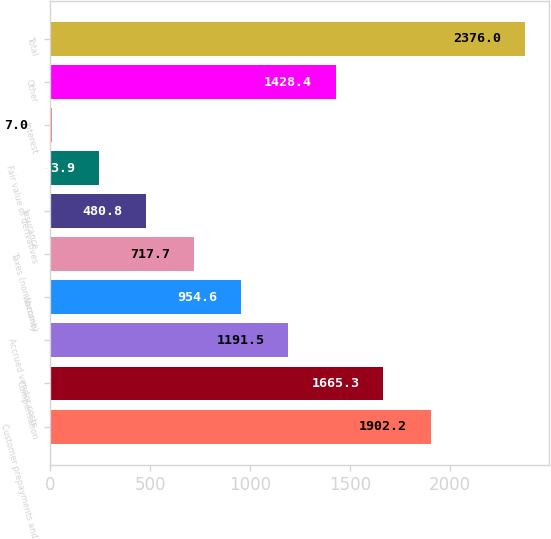Convert chart to OTSL. <chart><loc_0><loc_0><loc_500><loc_500><bar_chart><fcel>Customer prepayments and<fcel>Compensation<fcel>Accrued vendor costs<fcel>Warranty<fcel>Taxes (non income)<fcel>Insurance<fcel>Fair value of derivatives<fcel>Interest<fcel>Other<fcel>Total<nl><fcel>1902.2<fcel>1665.3<fcel>1191.5<fcel>954.6<fcel>717.7<fcel>480.8<fcel>243.9<fcel>7<fcel>1428.4<fcel>2376<nl></chart> 